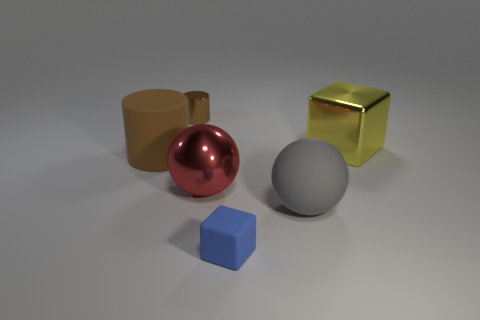There is a tiny thing in front of the large brown cylinder; is it the same shape as the big metallic object that is behind the big brown rubber cylinder?
Your answer should be very brief. Yes. What number of other brown things have the same material as the small brown thing?
Your answer should be very brief. 0. What is the shape of the shiny thing that is behind the large brown cylinder and on the left side of the large yellow metal block?
Provide a succinct answer. Cylinder. Is the material of the brown cylinder in front of the tiny cylinder the same as the big gray object?
Your answer should be very brief. Yes. The rubber cylinder that is the same size as the gray object is what color?
Keep it short and to the point. Brown. Are there any small things that have the same color as the big cylinder?
Provide a short and direct response. Yes. There is a brown cylinder that is the same material as the yellow thing; what size is it?
Your answer should be compact. Small. There is another cylinder that is the same color as the shiny cylinder; what size is it?
Offer a very short reply. Large. What number of other things are there of the same size as the blue cube?
Provide a succinct answer. 1. What material is the object on the left side of the brown metallic cylinder?
Your response must be concise. Rubber. 